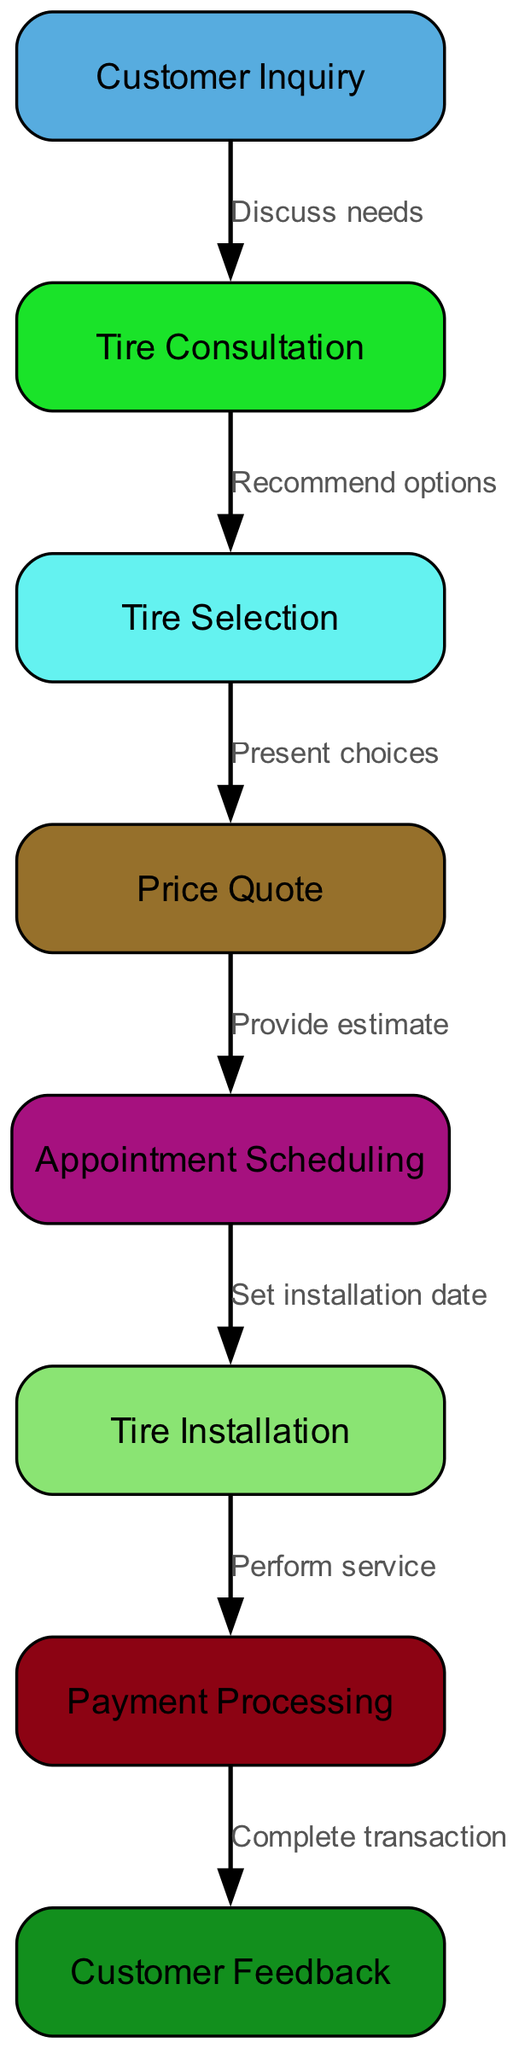What is the first step in the sales process? The diagram depicts "Customer Inquiry" as the first node, indicating that this step begins with customer inquiries.
Answer: Customer Inquiry How many nodes are present in the diagram? By counting each labeled segment within the provided diagram, there are eight distinct nodes showing each step of the tire shop sales process.
Answer: 8 What edge connects "Tire Consultation" to "Tire Selection"? The diagram shows that "Tire Consultation" is related to "Tire Selection" through the edge labeled "Recommend options", indicating this is how we move from consultation to selection.
Answer: Recommend options What step comes after "Tire Installation"? Following "Tire Installation," the next step indicated in the diagram is "Payment Processing" which shows the sequence in the sales process leading to the payment phase.
Answer: Payment Processing Which node does the edge labeled "Gather satisfaction data" originate from? In the diagram, "Gather satisfaction data" is the edge leading out from "Customer Feedback", representing the final step in the process where feedback is collected.
Answer: Customer Feedback Which two nodes are directly connected by the edge "Set installation date"? The connection labeled "Set installation date" appears between the nodes "Appointment Scheduling" and "Tire Installation," illustrating the link in the flow from scheduling to execution of the installation.
Answer: Appointment Scheduling and Tire Installation How many edges are there in total? The total number of edges can be calculated based on the connections between nodes; with seven edges outlined between the eight nodes, this completes the sales process flow in the diagram.
Answer: 7 What flow occurs between "Price Quote" and "Appointment Scheduling"? The edge labeled "Set installation date" signifies the flow from "Price Quote" directly into "Appointment Scheduling", showing that once a price is quoted, scheduling the installation can follow.
Answer: Set installation date 